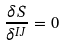Convert formula to latex. <formula><loc_0><loc_0><loc_500><loc_500>\frac { \delta S } { { \delta } ^ { I J } } = 0</formula> 